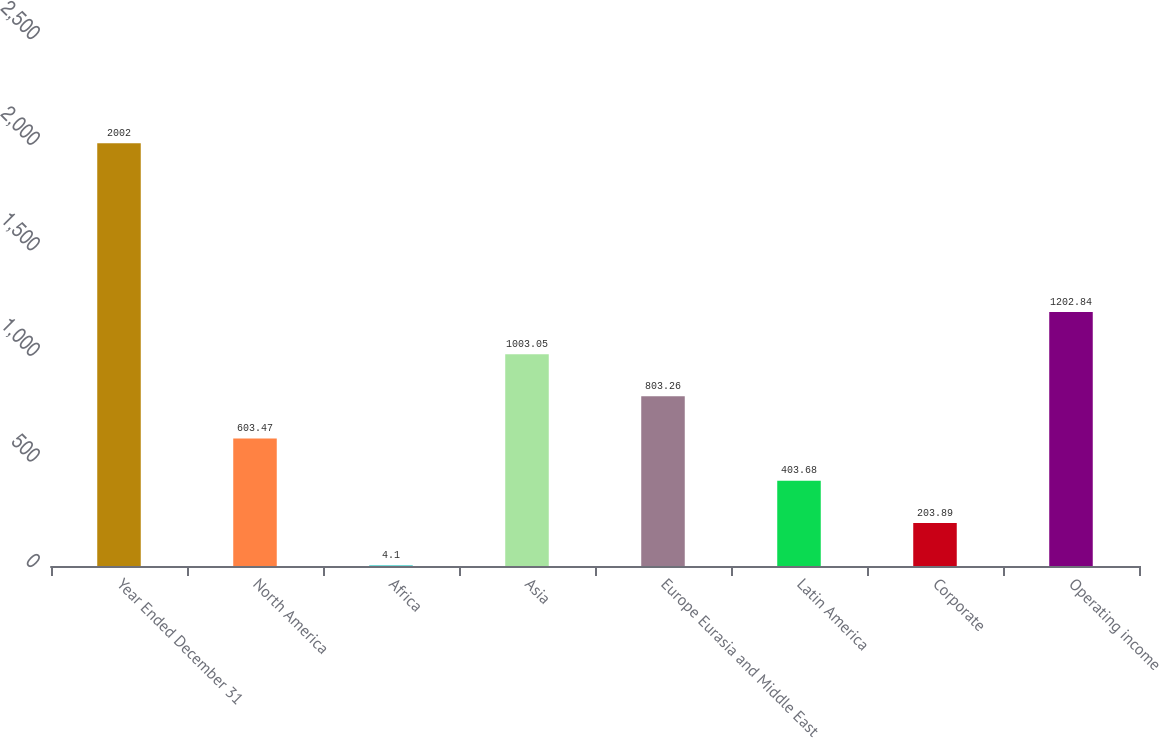Convert chart to OTSL. <chart><loc_0><loc_0><loc_500><loc_500><bar_chart><fcel>Year Ended December 31<fcel>North America<fcel>Africa<fcel>Asia<fcel>Europe Eurasia and Middle East<fcel>Latin America<fcel>Corporate<fcel>Operating income<nl><fcel>2002<fcel>603.47<fcel>4.1<fcel>1003.05<fcel>803.26<fcel>403.68<fcel>203.89<fcel>1202.84<nl></chart> 